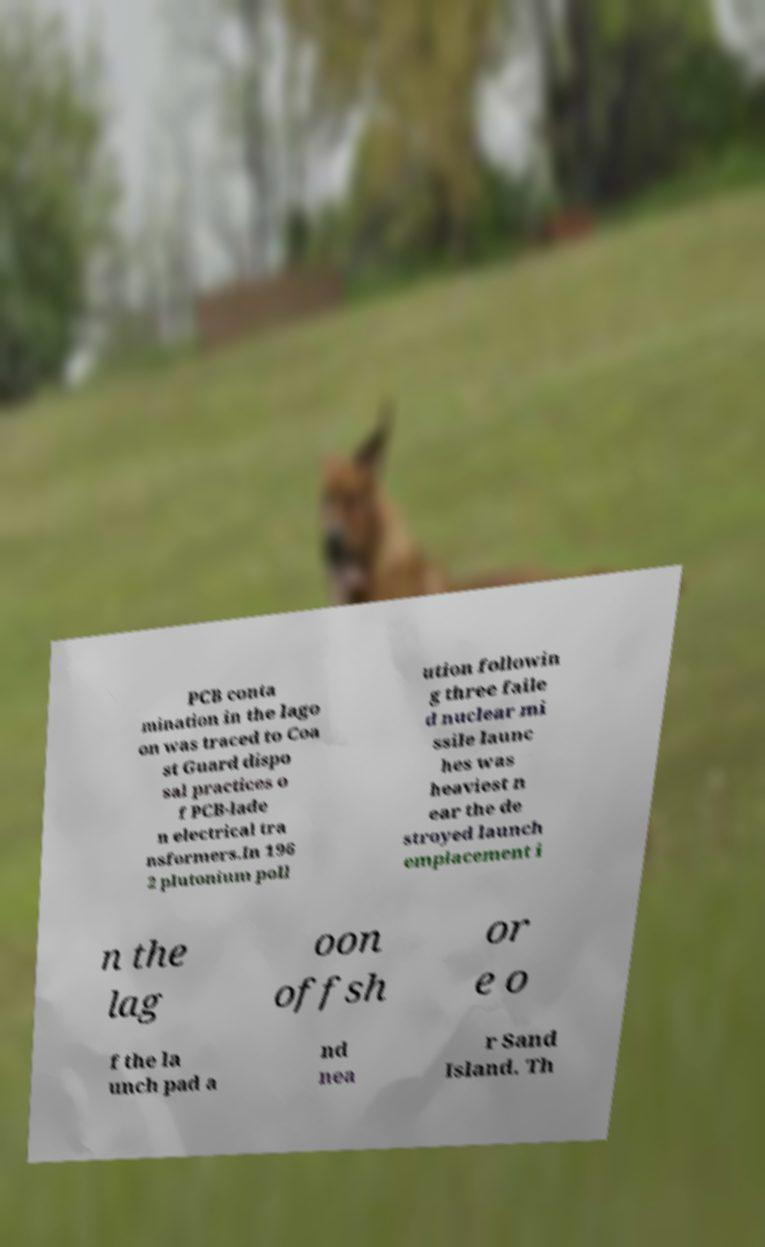There's text embedded in this image that I need extracted. Can you transcribe it verbatim? PCB conta mination in the lago on was traced to Coa st Guard dispo sal practices o f PCB-lade n electrical tra nsformers.In 196 2 plutonium poll ution followin g three faile d nuclear mi ssile launc hes was heaviest n ear the de stroyed launch emplacement i n the lag oon offsh or e o f the la unch pad a nd nea r Sand Island. Th 